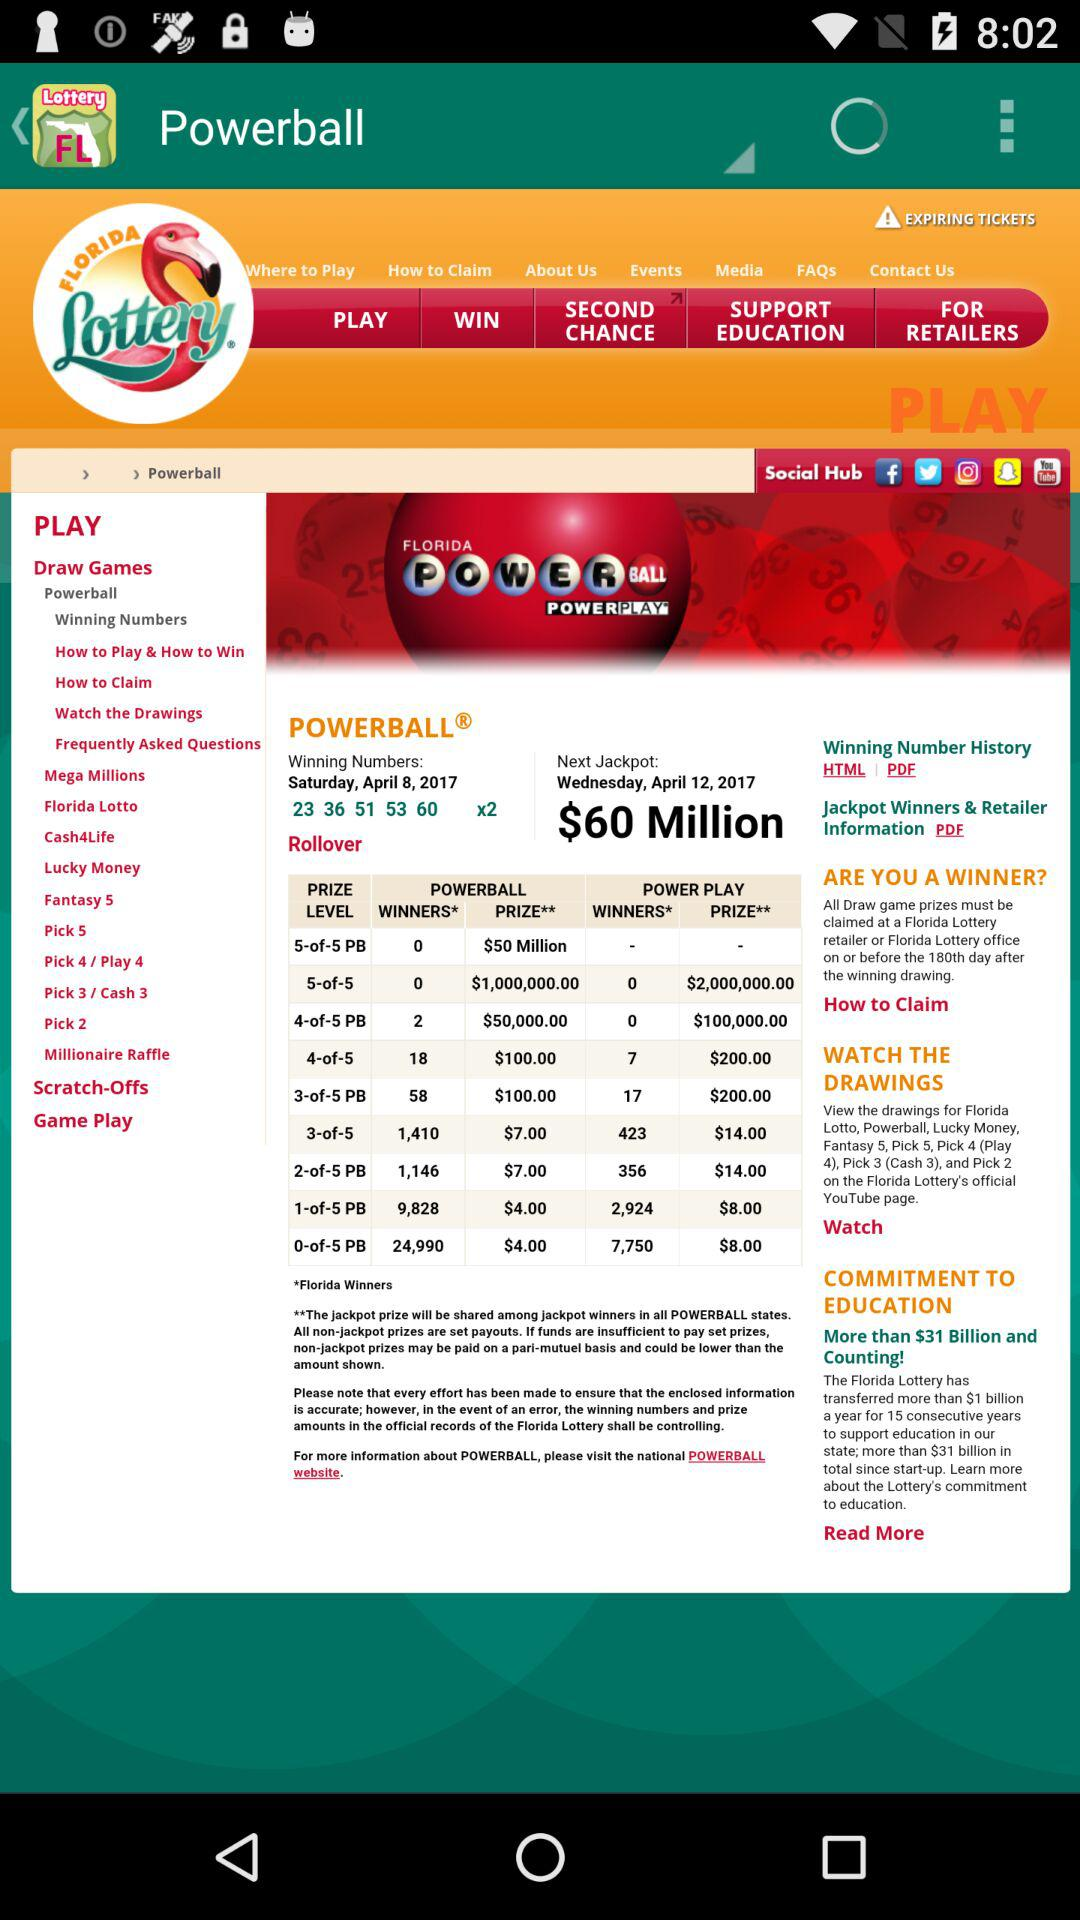What is the name of the application? The name of the application is "Florida Lottery Results". 